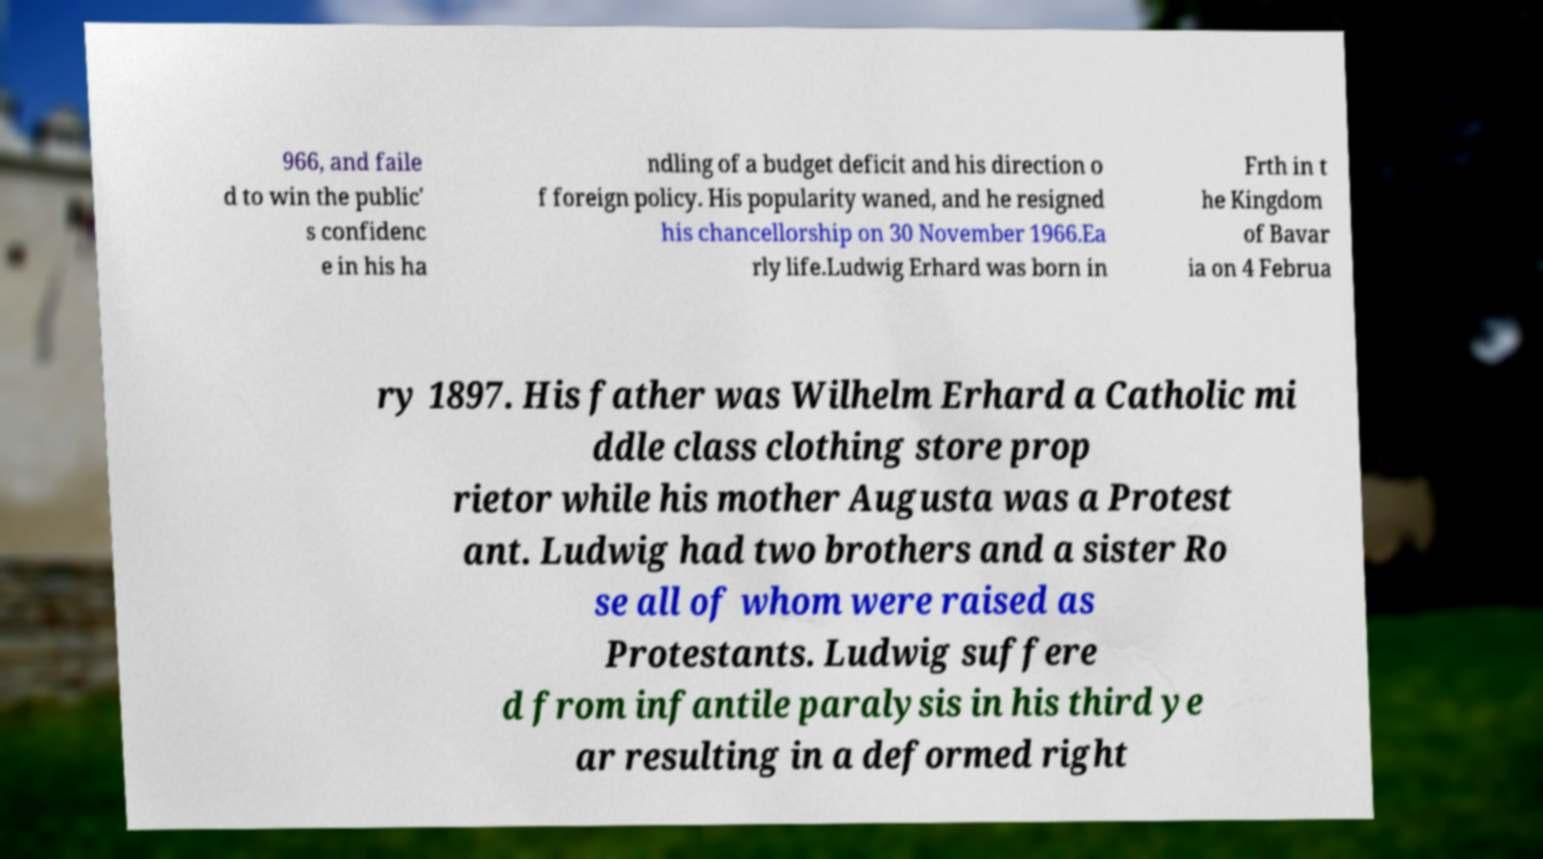Please read and relay the text visible in this image. What does it say? 966, and faile d to win the public' s confidenc e in his ha ndling of a budget deficit and his direction o f foreign policy. His popularity waned, and he resigned his chancellorship on 30 November 1966.Ea rly life.Ludwig Erhard was born in Frth in t he Kingdom of Bavar ia on 4 Februa ry 1897. His father was Wilhelm Erhard a Catholic mi ddle class clothing store prop rietor while his mother Augusta was a Protest ant. Ludwig had two brothers and a sister Ro se all of whom were raised as Protestants. Ludwig suffere d from infantile paralysis in his third ye ar resulting in a deformed right 